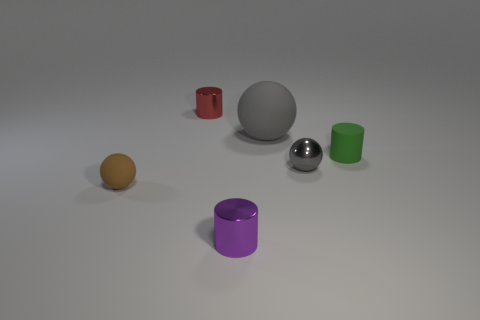Add 3 small matte cylinders. How many objects exist? 9 Subtract 0 blue cylinders. How many objects are left? 6 Subtract all large purple metal cubes. Subtract all cylinders. How many objects are left? 3 Add 5 metal cylinders. How many metal cylinders are left? 7 Add 4 big gray things. How many big gray things exist? 5 